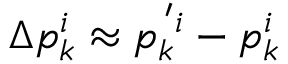<formula> <loc_0><loc_0><loc_500><loc_500>\Delta p _ { k } ^ { i } \approx p _ { k } ^ { \, ^ { \prime } i } - p _ { k } ^ { i }</formula> 